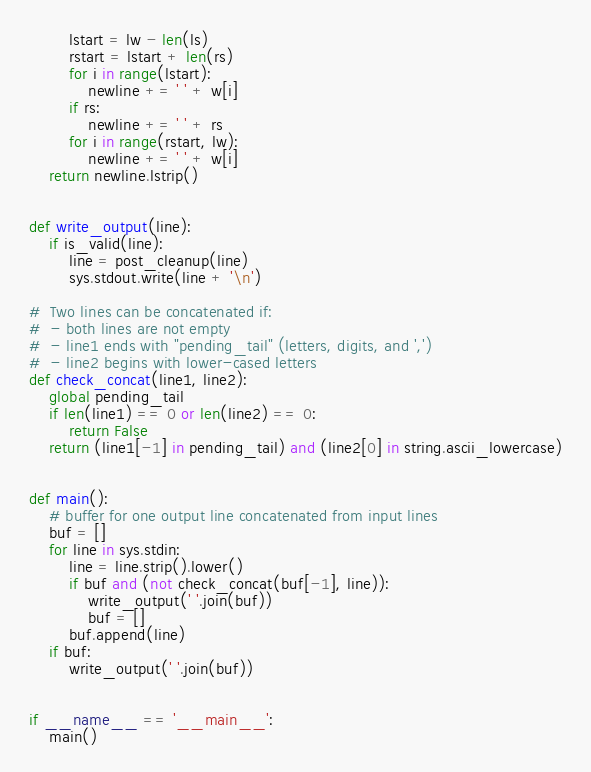Convert code to text. <code><loc_0><loc_0><loc_500><loc_500><_Python_>        lstart = lw - len(ls)
        rstart = lstart + len(rs)
        for i in range(lstart):
            newline += ' ' + w[i]
        if rs:
            newline += ' ' + rs
        for i in range(rstart, lw):
            newline += ' ' + w[i]
    return newline.lstrip()


def write_output(line):
    if is_valid(line):
        line = post_cleanup(line)
        sys.stdout.write(line + '\n')

#  Two lines can be concatenated if:
#  - both lines are not empty
#  - line1 ends with "pending_tail" (letters, digits, and ',')
#  - line2 begins with lower-cased letters
def check_concat(line1, line2):
    global pending_tail
    if len(line1) == 0 or len(line2) == 0:
        return False
    return (line1[-1] in pending_tail) and (line2[0] in string.ascii_lowercase)


def main():
    # buffer for one output line concatenated from input lines
    buf = []
    for line in sys.stdin:
        line = line.strip().lower()
        if buf and (not check_concat(buf[-1], line)):
            write_output(' '.join(buf))
            buf = []
        buf.append(line)
    if buf:
        write_output(' '.join(buf))


if __name__ == '__main__':
    main()
</code> 